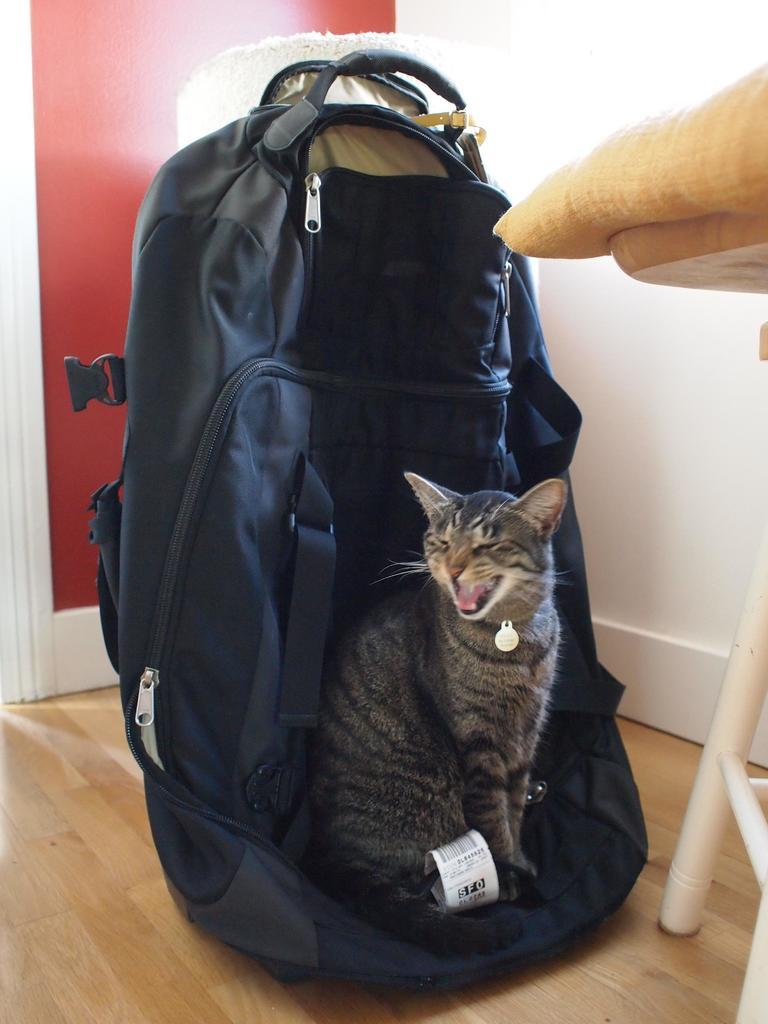What animal can be seen in the image? There is a cat in the image. What is the cat sitting on? The cat is sitting on a bag. What color is the wall in the background of the image? There is a red wall in the background of the image. What type of furniture is visible to the right of the image? There is a chair visible to the right of the image. What type of cork is being used to hold up the curtain in the image? There is no cork or curtain present in the image; it features a cat sitting on a bag with a red wall in the background and a chair visible to the right. 